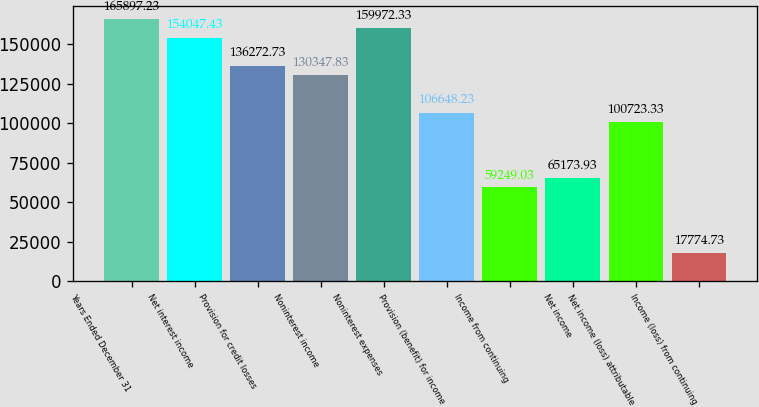Convert chart. <chart><loc_0><loc_0><loc_500><loc_500><bar_chart><fcel>Years Ended December 31<fcel>Net interest income<fcel>Provision for credit losses<fcel>Noninterest income<fcel>Noninterest expenses<fcel>Provision (benefit) for income<fcel>Income from continuing<fcel>Net income<fcel>Net income (loss) attributable<fcel>Income (loss) from continuing<nl><fcel>165897<fcel>154047<fcel>136273<fcel>130348<fcel>159972<fcel>106648<fcel>59249<fcel>65173.9<fcel>100723<fcel>17774.7<nl></chart> 